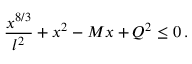Convert formula to latex. <formula><loc_0><loc_0><loc_500><loc_500>{ \frac { x ^ { 8 / 3 } } { l ^ { 2 } } } + x ^ { 2 } - M x + Q ^ { 2 } \leq 0 \, .</formula> 